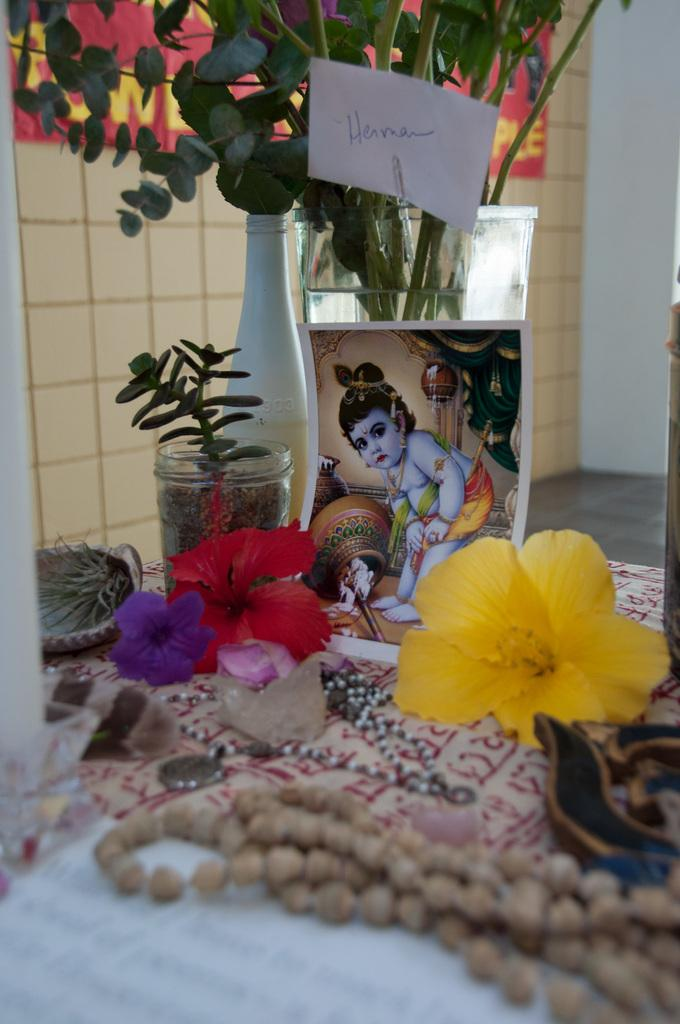What objects are present in the image that contain plants? There are flower vases in the image that contain plants. What is placed in front of the flower vases? There is a photo, plants, beads, and other objects in front of the flower vases. Can you describe the contents of the photo? The provided facts do not give information about the contents of the photo. What type of beads are present in front of the flower vases? The provided facts do not specify the type of beads present in front of the flower vases. How many flocks of birds can be seen flying over the flower vases in the image? There are no flocks of birds visible in the image. What is the size of the list of objects in front of the flower vases? There is no list of objects mentioned in the image, so it is impossible to determine its size. 